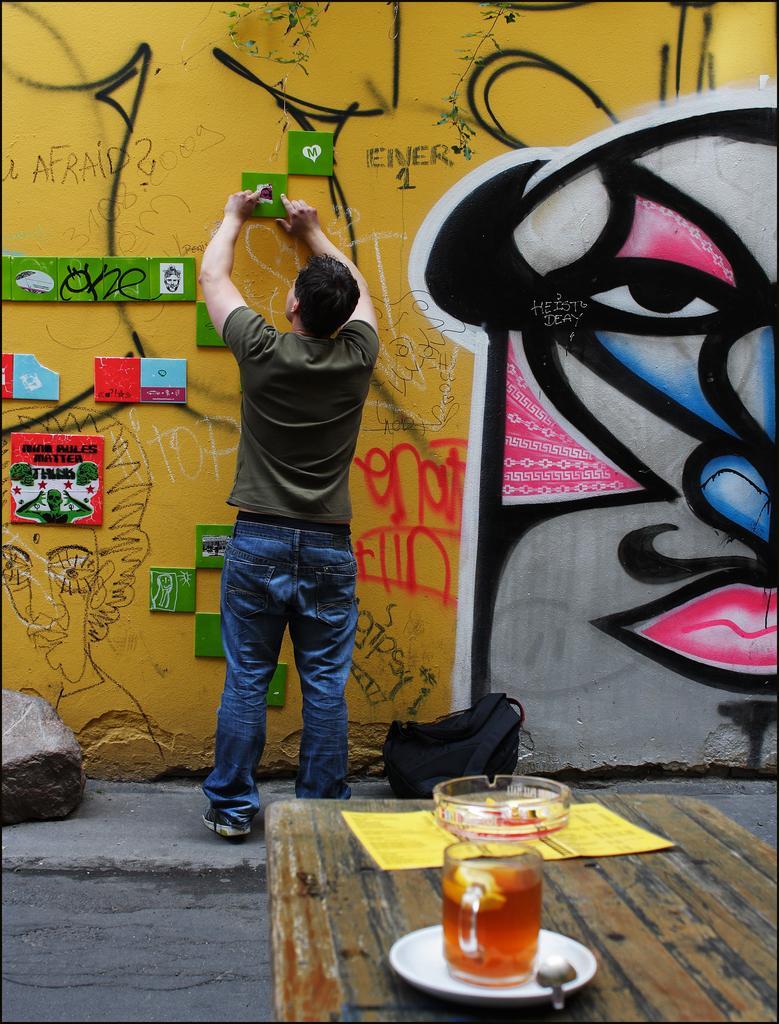Describe this image in one or two sentences. In the picture I can see a man is standing and wearing a t-shirt, blue jeans and shoes. In front of the image I can see a table which has a glass, saucers, spoon and some other objects. I can also see painting on the wall and some other objects attached to it. 